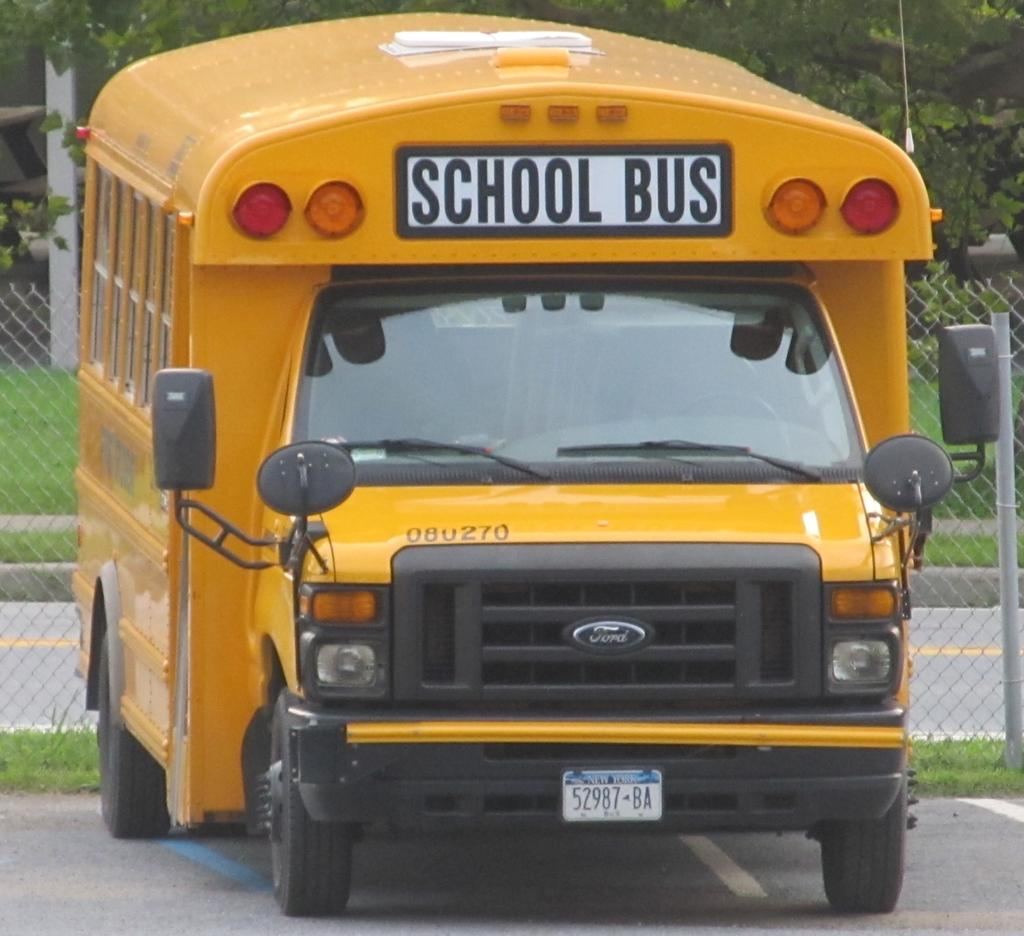<image>
Provide a brief description of the given image. A yellow bus with a large sign that reads school bus. 